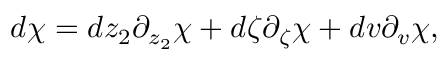Convert formula to latex. <formula><loc_0><loc_0><loc_500><loc_500>d \chi = d z _ { 2 } \partial _ { z _ { 2 } } \chi + d \zeta \partial _ { \zeta } \chi + d v \partial _ { v } \chi ,</formula> 